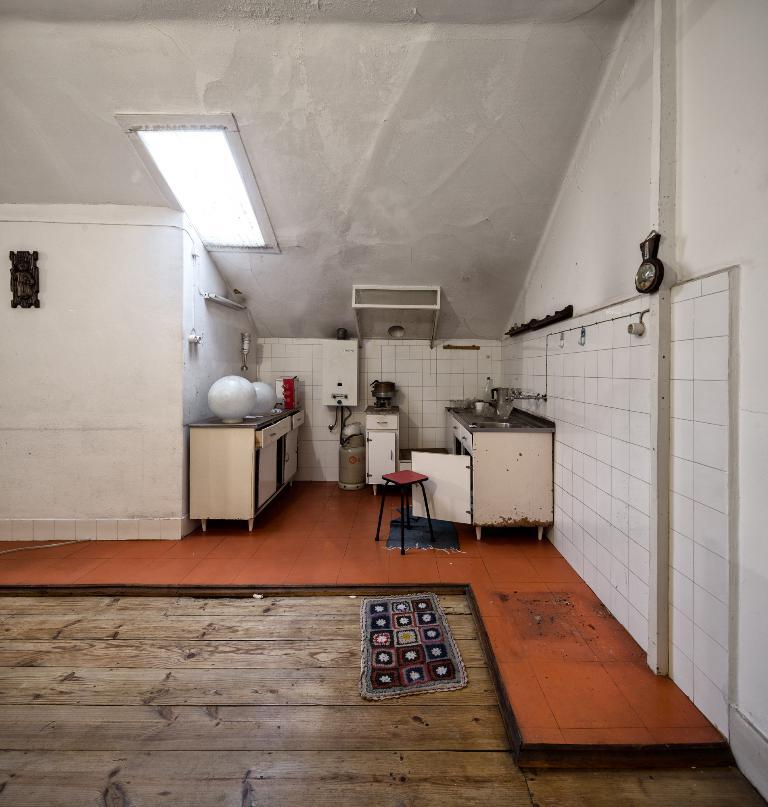What type of room is shown in the image? The image shows an inner view of a room. What can be found in the room for washing purposes? There is a sink and taps in the room. What is available for sitting in the room? There is a stool in the room. Where can items be stored in the room? There are cabinets in the room for storage. What type of equipment is present in the room? There is electric equipment in the room. What is placed near the entrance of the room? There is a doormat in the room. How is the room illuminated? There is an electric light attached to the roof. How many rabbits can be seen playing with liquid in the room? There are no rabbits or liquid present in the room; the image shows an interior room with various objects and features. 